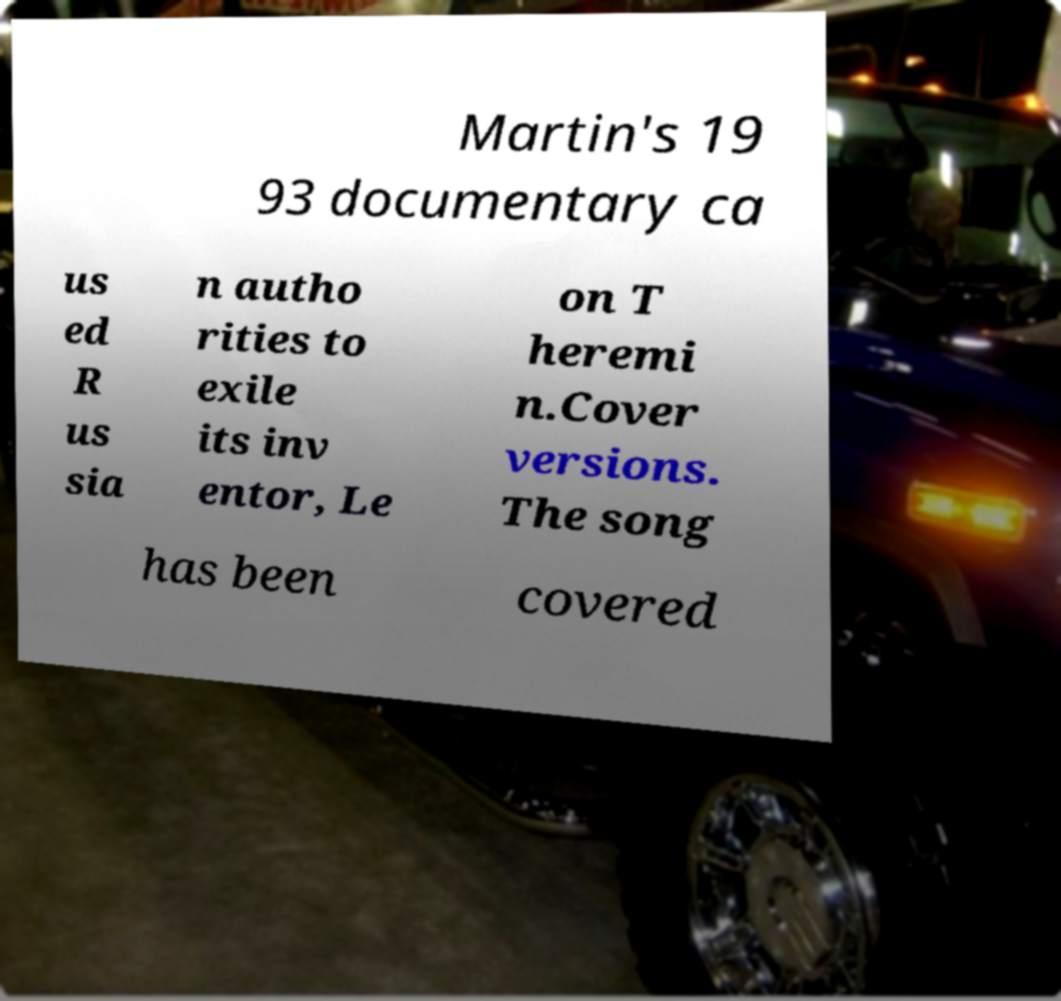Can you read and provide the text displayed in the image?This photo seems to have some interesting text. Can you extract and type it out for me? Martin's 19 93 documentary ca us ed R us sia n autho rities to exile its inv entor, Le on T heremi n.Cover versions. The song has been covered 